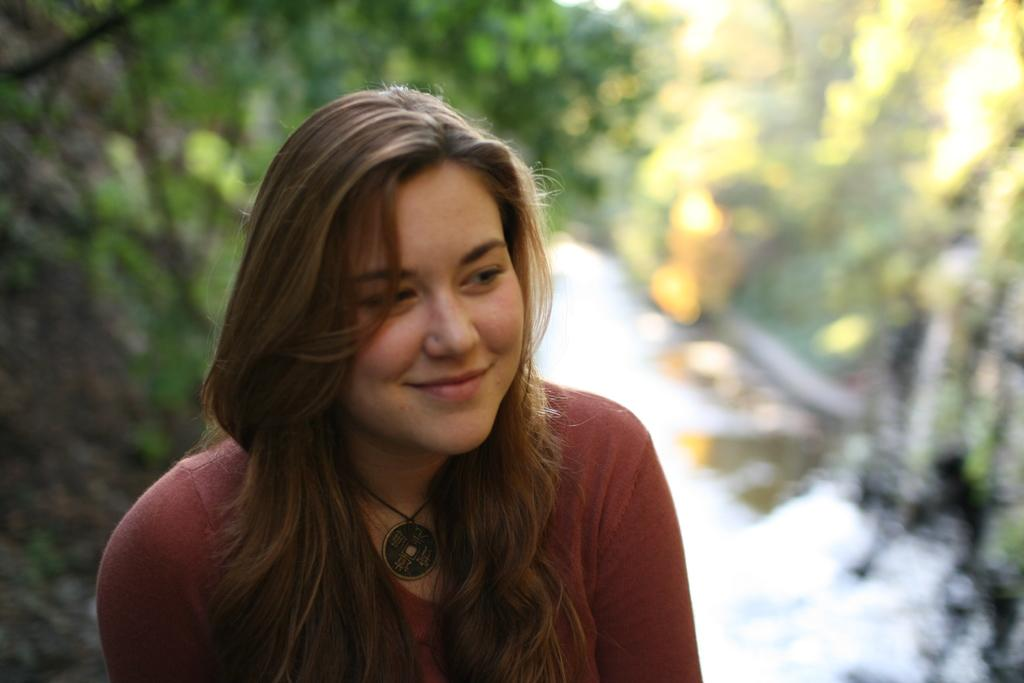What can be observed about the background of the image? The background portion of the picture is blurred. What type of natural elements can be seen in the image? There are trees visible in the image. Who is present in the image? There is a woman in the picture. What is the woman's expression in the image? The woman is smiling. What type of shoe is the woman wearing in the image? There is no information about the woman's shoes in the image, so we cannot determine what type of shoe she is wearing. 